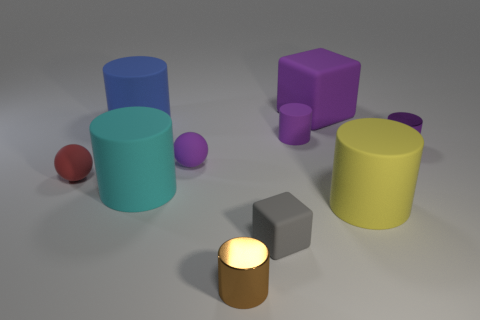How many small metal cylinders are in front of the rubber thing on the right side of the big purple thing behind the cyan cylinder?
Provide a short and direct response. 1. There is a matte ball that is the same color as the big block; what size is it?
Provide a succinct answer. Small. Are there any cyan objects to the right of the gray matte thing?
Keep it short and to the point. No. What shape is the small brown metal object?
Keep it short and to the point. Cylinder. What shape is the tiny shiny object right of the shiny cylinder to the left of the metal cylinder right of the brown cylinder?
Provide a short and direct response. Cylinder. What number of other things are the same shape as the large yellow rubber object?
Your answer should be compact. 5. There is a purple thing on the left side of the metal cylinder that is on the left side of the large cube; what is it made of?
Ensure brevity in your answer.  Rubber. Are there any other things that have the same size as the yellow matte object?
Offer a very short reply. Yes. Are the small red ball and the tiny purple thing that is right of the big yellow rubber cylinder made of the same material?
Your response must be concise. No. There is a big cylinder that is both in front of the purple shiny cylinder and left of the yellow matte cylinder; what is its material?
Ensure brevity in your answer.  Rubber. 